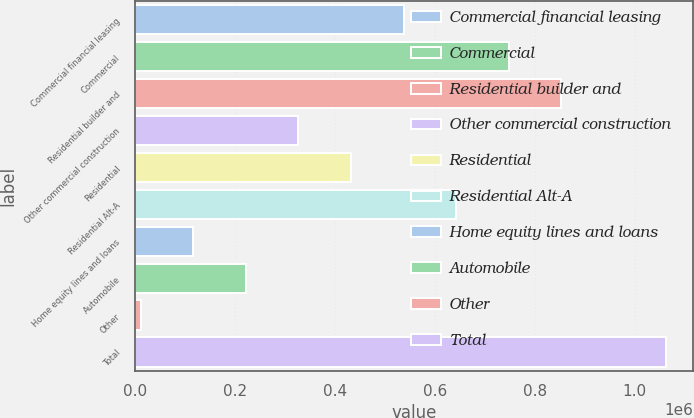Convert chart to OTSL. <chart><loc_0><loc_0><loc_500><loc_500><bar_chart><fcel>Commercial financial leasing<fcel>Commercial<fcel>Residential builder and<fcel>Other commercial construction<fcel>Residential<fcel>Residential Alt-A<fcel>Home equity lines and loans<fcel>Automobile<fcel>Other<fcel>Total<nl><fcel>537405<fcel>747956<fcel>853231<fcel>326854<fcel>432130<fcel>642680<fcel>116303<fcel>221579<fcel>11028<fcel>1.06378e+06<nl></chart> 